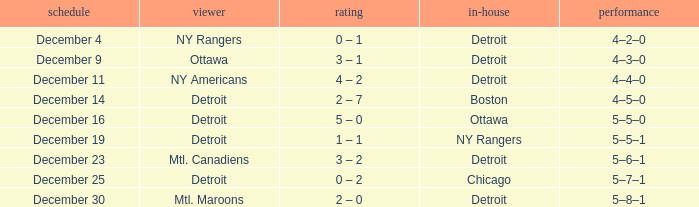What score has detroit as the home, and December 9 as the date? 3 – 1. 